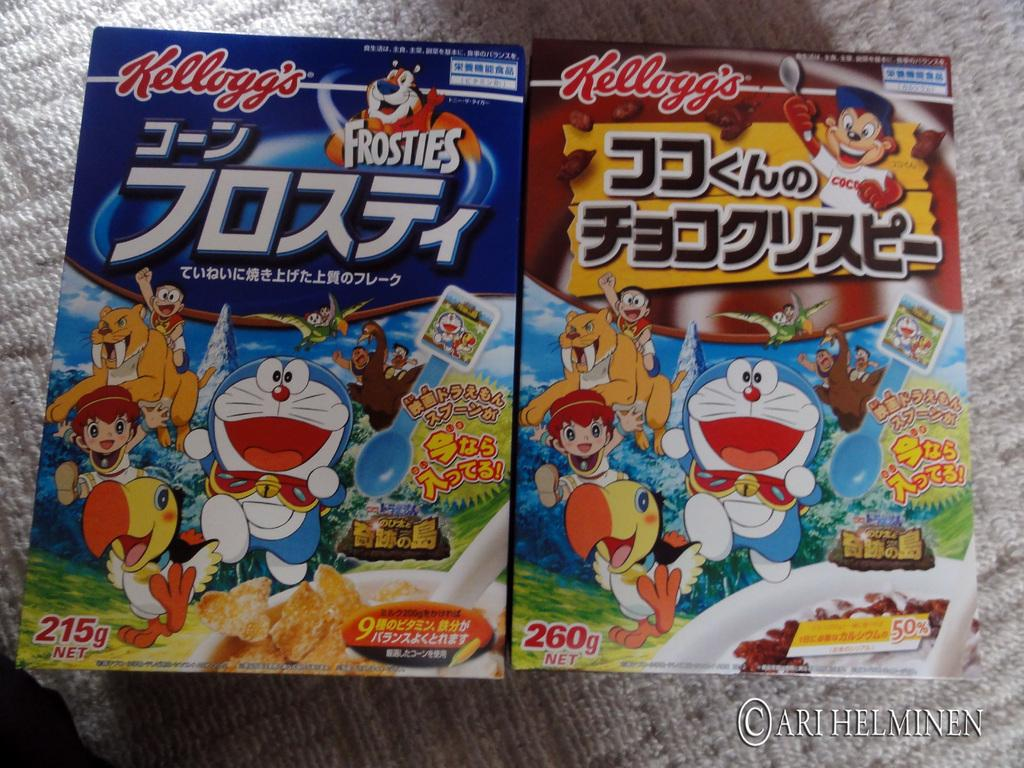What is on the floor in the image? There are covers on the floor. What can be seen on the covers? There is text, cartoon images of animals, and cartoon images of persons on the covers. What elements are present in the cartoon images? Balloons, trees, numbers, and food items are present in the cartoon images. Where is the arch located in the image? There is no arch present in the image. What type of seat can be seen in the image? There is no seat present in the image. 